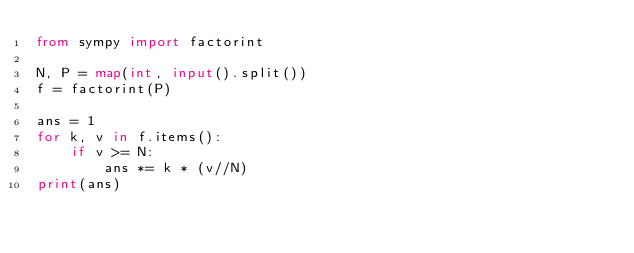Convert code to text. <code><loc_0><loc_0><loc_500><loc_500><_Python_>from sympy import factorint

N, P = map(int, input().split())
f = factorint(P)

ans = 1
for k, v in f.items():
    if v >= N:
        ans *= k * (v//N)
print(ans)
</code> 